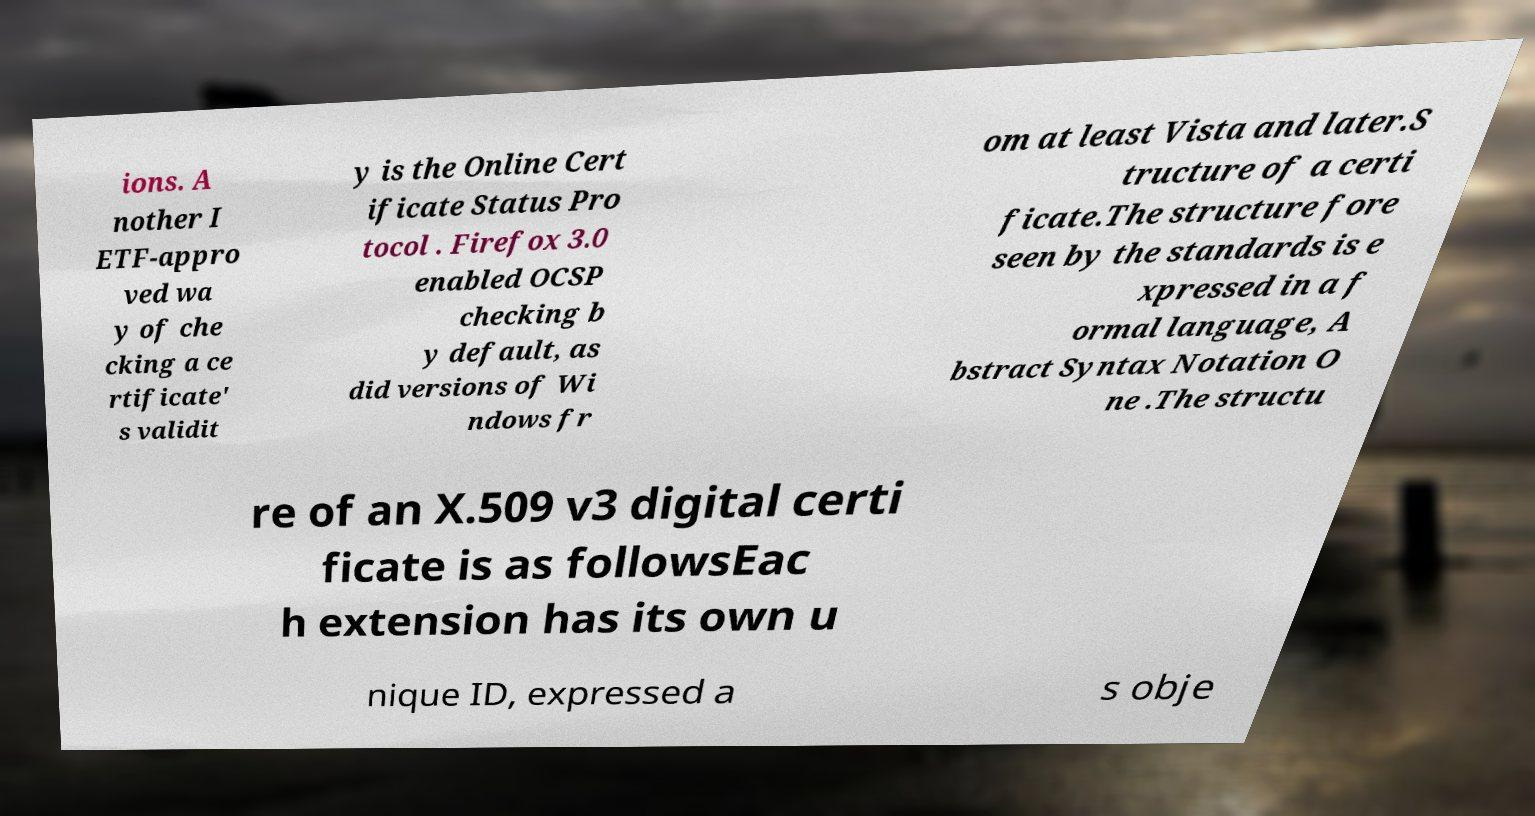There's text embedded in this image that I need extracted. Can you transcribe it verbatim? ions. A nother I ETF-appro ved wa y of che cking a ce rtificate' s validit y is the Online Cert ificate Status Pro tocol . Firefox 3.0 enabled OCSP checking b y default, as did versions of Wi ndows fr om at least Vista and later.S tructure of a certi ficate.The structure fore seen by the standards is e xpressed in a f ormal language, A bstract Syntax Notation O ne .The structu re of an X.509 v3 digital certi ficate is as followsEac h extension has its own u nique ID, expressed a s obje 